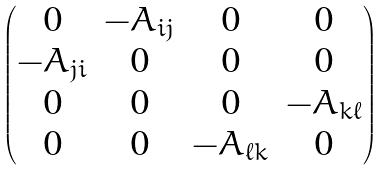<formula> <loc_0><loc_0><loc_500><loc_500>\begin{pmatrix} 0 & - A _ { i j } & 0 & 0 \\ - A _ { j i } & 0 & 0 & 0 \\ 0 & 0 & 0 & - A _ { k \ell } \\ 0 & 0 & - A _ { \ell k } & 0 \end{pmatrix}</formula> 